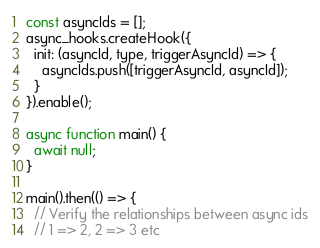<code> <loc_0><loc_0><loc_500><loc_500><_JavaScript_>const asyncIds = [];
async_hooks.createHook({
  init: (asyncId, type, triggerAsyncId) => {
    asyncIds.push([triggerAsyncId, asyncId]);
  }
}).enable();

async function main() {
  await null;
}

main().then(() => {
  // Verify the relationships between async ids
  // 1 => 2, 2 => 3 etc</code> 